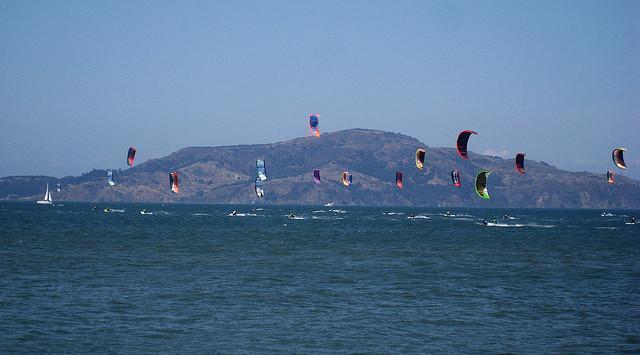Which direction does the wind blow?
Pick the correct solution from the four options below to address the question.
Options: Toward boat, rightward, from hills, up down. Toward boat. 